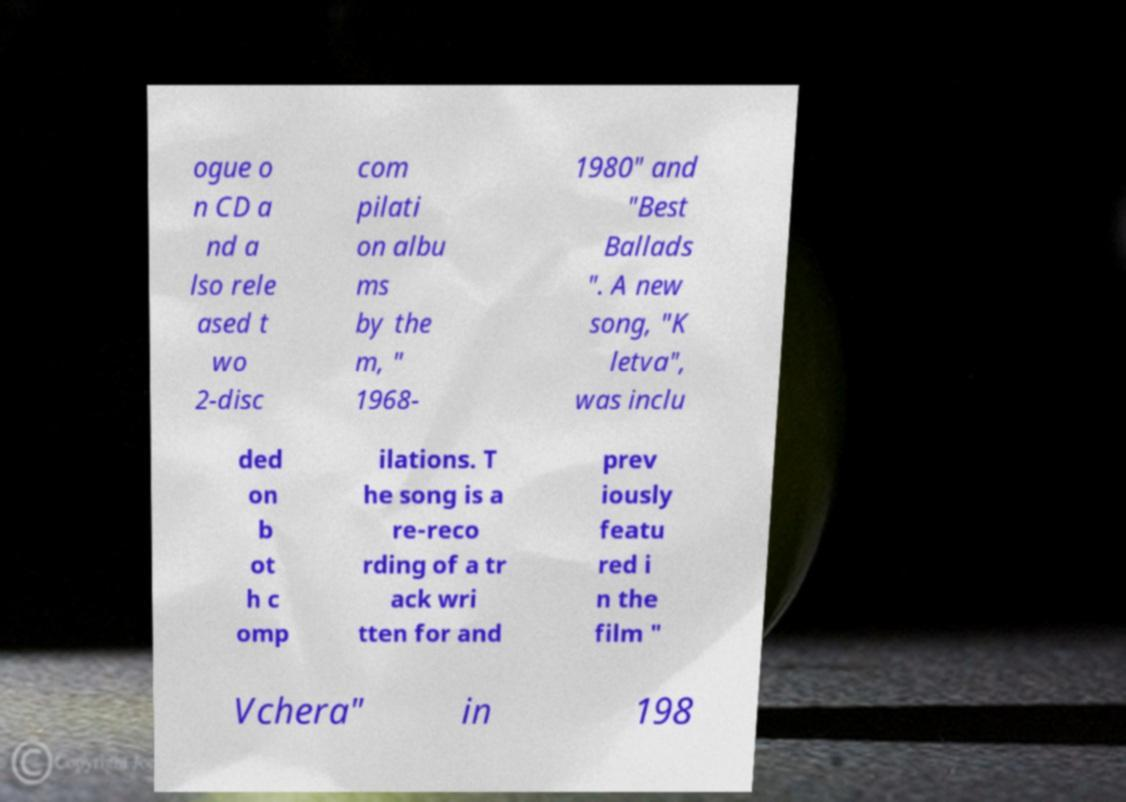Can you read and provide the text displayed in the image?This photo seems to have some interesting text. Can you extract and type it out for me? ogue o n CD a nd a lso rele ased t wo 2-disc com pilati on albu ms by the m, " 1968- 1980" and "Best Ballads ". A new song, "K letva", was inclu ded on b ot h c omp ilations. T he song is a re-reco rding of a tr ack wri tten for and prev iously featu red i n the film " Vchera" in 198 